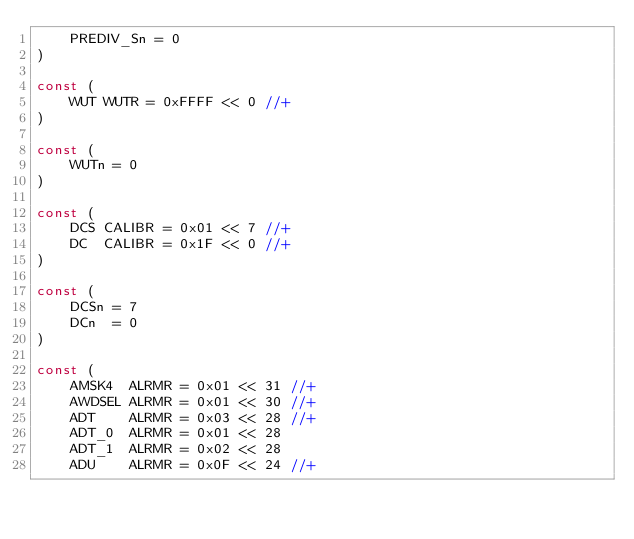<code> <loc_0><loc_0><loc_500><loc_500><_Go_>	PREDIV_Sn = 0
)

const (
	WUT WUTR = 0xFFFF << 0 //+
)

const (
	WUTn = 0
)

const (
	DCS CALIBR = 0x01 << 7 //+
	DC  CALIBR = 0x1F << 0 //+
)

const (
	DCSn = 7
	DCn  = 0
)

const (
	AMSK4  ALRMR = 0x01 << 31 //+
	AWDSEL ALRMR = 0x01 << 30 //+
	ADT    ALRMR = 0x03 << 28 //+
	ADT_0  ALRMR = 0x01 << 28
	ADT_1  ALRMR = 0x02 << 28
	ADU    ALRMR = 0x0F << 24 //+</code> 